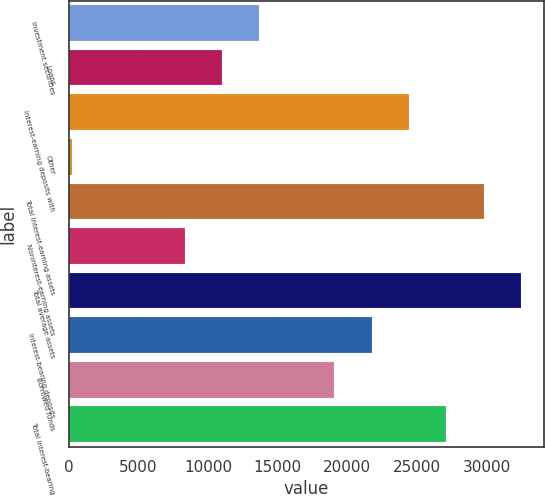Convert chart to OTSL. <chart><loc_0><loc_0><loc_500><loc_500><bar_chart><fcel>Investment securities<fcel>Loans<fcel>Interest-earning deposits with<fcel>Other<fcel>Total interest-earning assets<fcel>Noninterest-earning assets<fcel>Total average assets<fcel>Interest-bearing deposits<fcel>Borrowed funds<fcel>Total interest-bearing<nl><fcel>13690.5<fcel>11006.4<fcel>24426.9<fcel>270<fcel>29795.1<fcel>8322.3<fcel>32479.2<fcel>21742.8<fcel>19058.7<fcel>27111<nl></chart> 